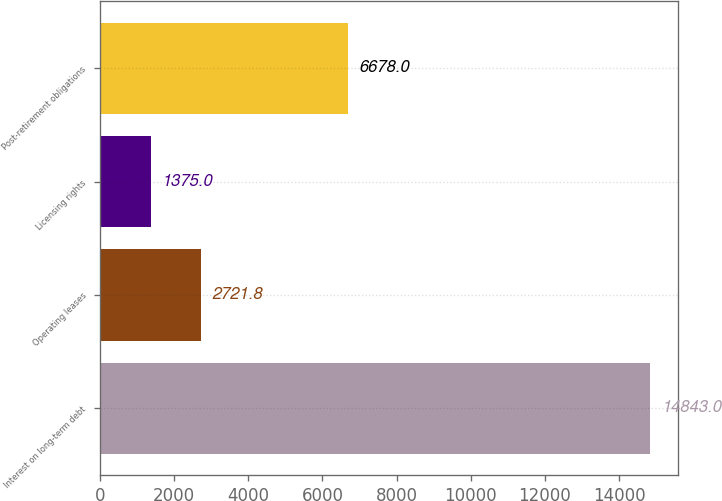Convert chart to OTSL. <chart><loc_0><loc_0><loc_500><loc_500><bar_chart><fcel>Interest on long-term debt<fcel>Operating leases<fcel>Licensing rights<fcel>Post-retirement obligations<nl><fcel>14843<fcel>2721.8<fcel>1375<fcel>6678<nl></chart> 